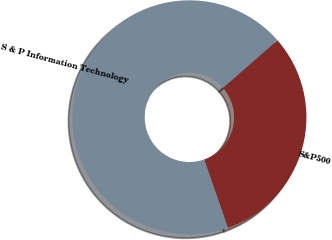Convert chart to OTSL. <chart><loc_0><loc_0><loc_500><loc_500><pie_chart><fcel>S&P500<fcel>S & P Information Technology<nl><fcel>31.1%<fcel>68.9%<nl></chart> 